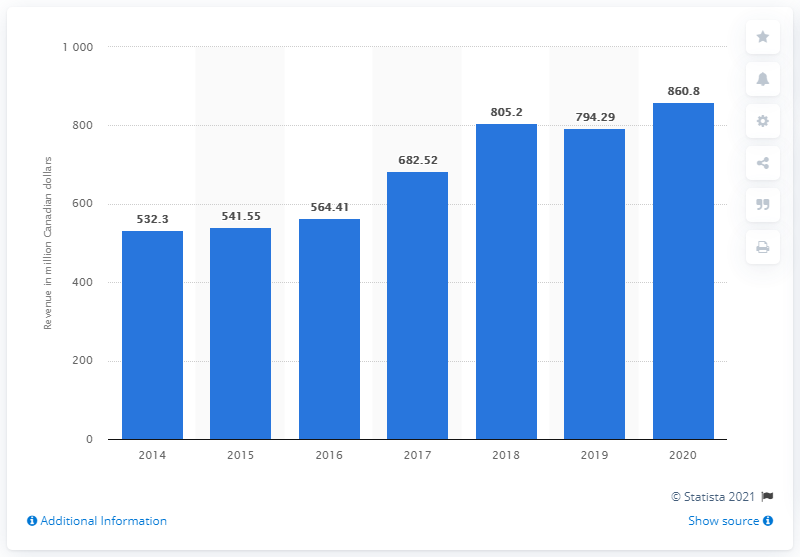Outline some significant characteristics in this image. In 2020, the revenue of Rogers Sugar Inc. in Canadian dollars was CAD 860.8 million. The revenue of Rogers Sugar Inc. in the previous year was 794.29 million dollars. 